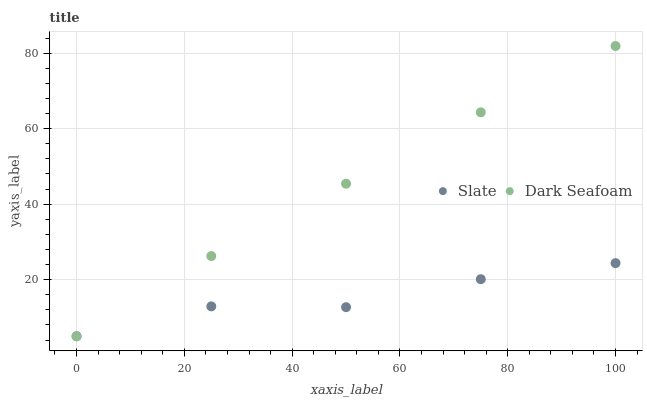Does Slate have the minimum area under the curve?
Answer yes or no. Yes. Does Dark Seafoam have the maximum area under the curve?
Answer yes or no. Yes. Does Dark Seafoam have the minimum area under the curve?
Answer yes or no. No. Is Dark Seafoam the smoothest?
Answer yes or no. Yes. Is Slate the roughest?
Answer yes or no. Yes. Is Dark Seafoam the roughest?
Answer yes or no. No. Does Slate have the lowest value?
Answer yes or no. Yes. Does Dark Seafoam have the highest value?
Answer yes or no. Yes. Does Dark Seafoam intersect Slate?
Answer yes or no. Yes. Is Dark Seafoam less than Slate?
Answer yes or no. No. Is Dark Seafoam greater than Slate?
Answer yes or no. No. 